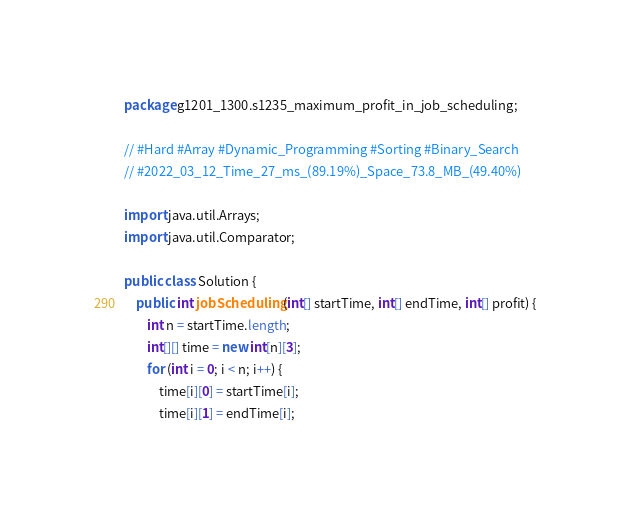<code> <loc_0><loc_0><loc_500><loc_500><_Java_>package g1201_1300.s1235_maximum_profit_in_job_scheduling;

// #Hard #Array #Dynamic_Programming #Sorting #Binary_Search
// #2022_03_12_Time_27_ms_(89.19%)_Space_73.8_MB_(49.40%)

import java.util.Arrays;
import java.util.Comparator;

public class Solution {
    public int jobScheduling(int[] startTime, int[] endTime, int[] profit) {
        int n = startTime.length;
        int[][] time = new int[n][3];
        for (int i = 0; i < n; i++) {
            time[i][0] = startTime[i];
            time[i][1] = endTime[i];</code> 